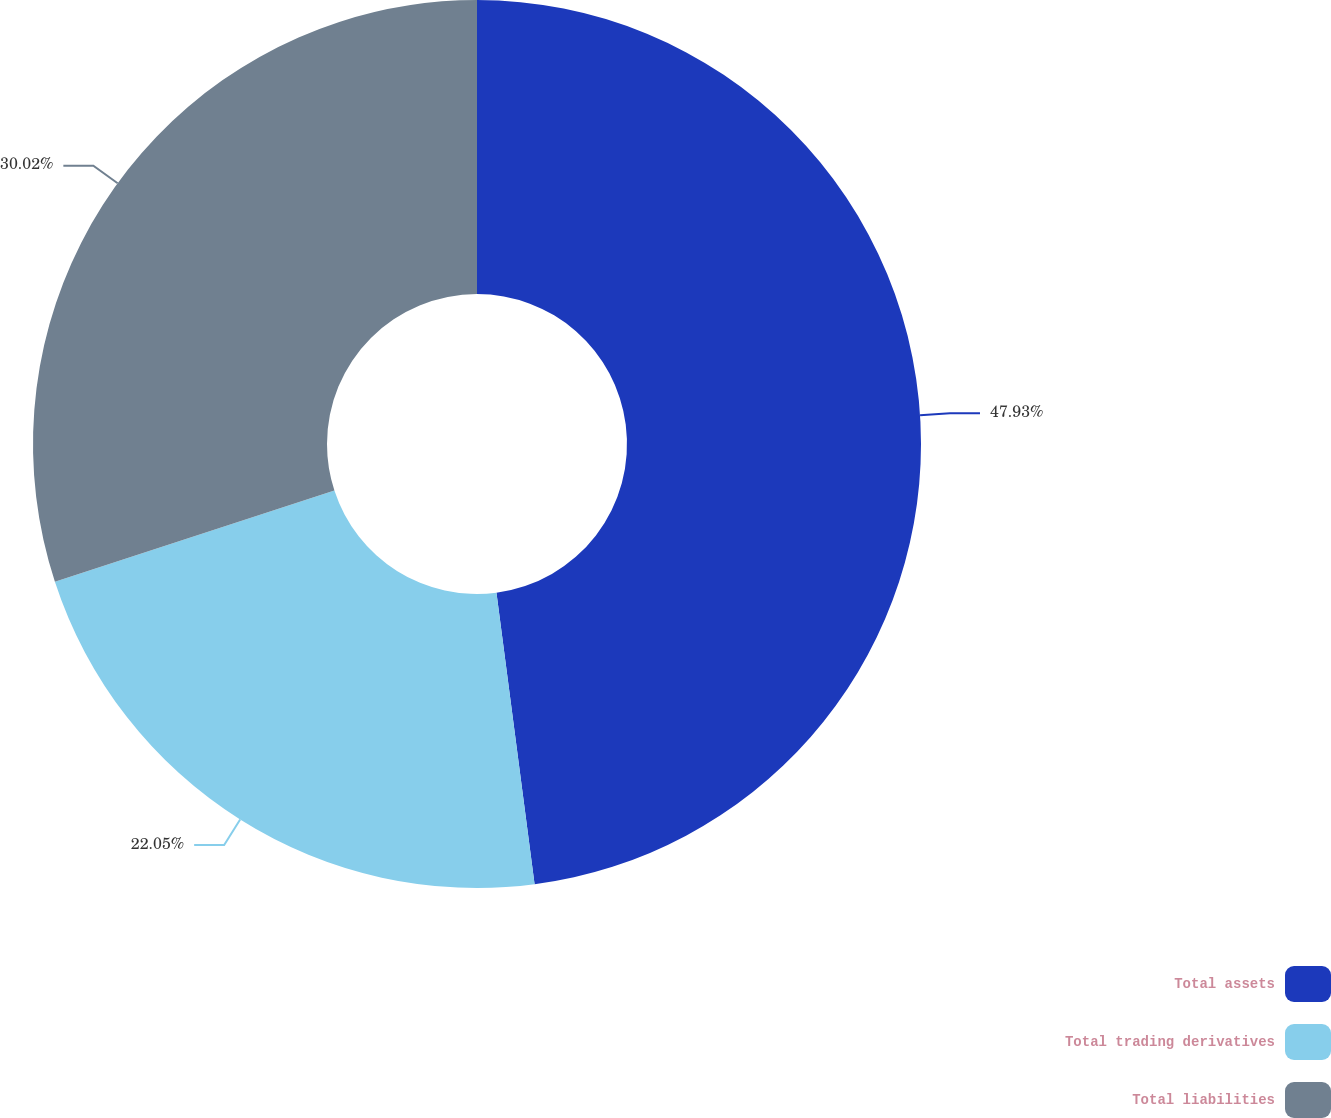Convert chart to OTSL. <chart><loc_0><loc_0><loc_500><loc_500><pie_chart><fcel>Total assets<fcel>Total trading derivatives<fcel>Total liabilities<nl><fcel>47.93%<fcel>22.05%<fcel>30.02%<nl></chart> 